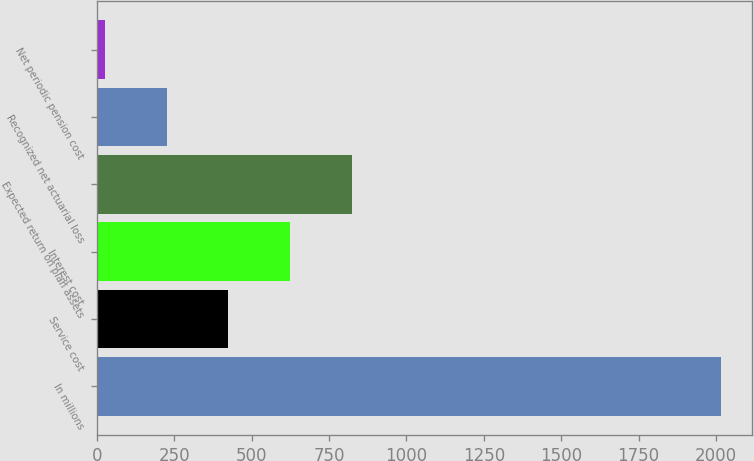Convert chart to OTSL. <chart><loc_0><loc_0><loc_500><loc_500><bar_chart><fcel>In millions<fcel>Service cost<fcel>Interest cost<fcel>Expected return on plan assets<fcel>Recognized net actuarial loss<fcel>Net periodic pension cost<nl><fcel>2016<fcel>424.8<fcel>623.7<fcel>822.6<fcel>225.9<fcel>27<nl></chart> 